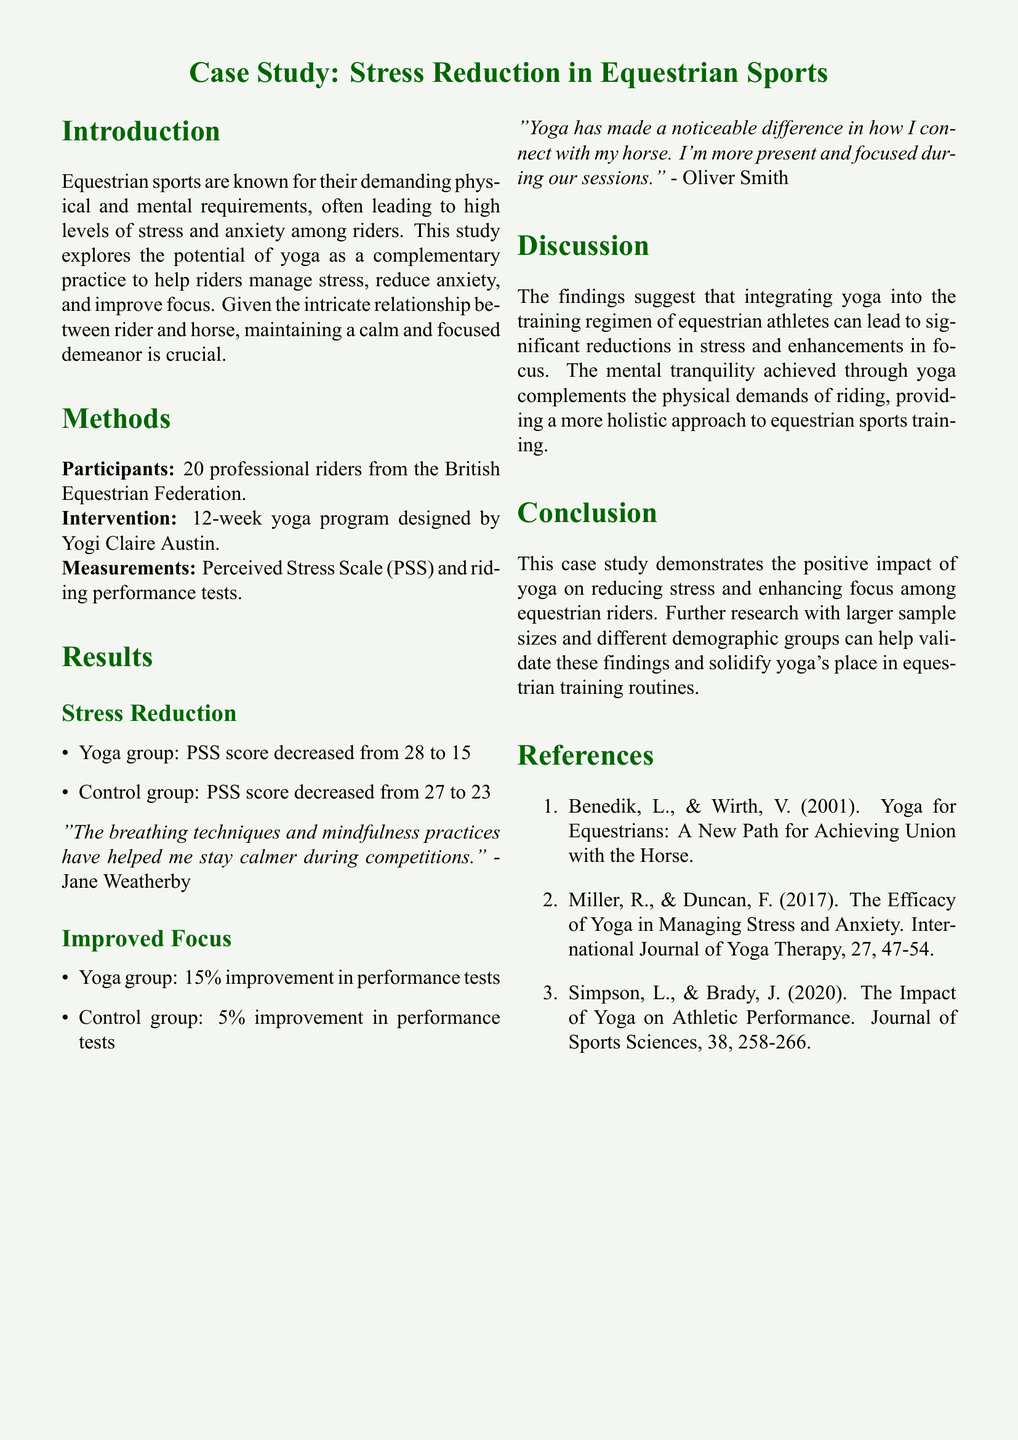What was the sample size for the study? The number of participants in the study is explicitly stated in the document, which refers to 20 professional riders.
Answer: 20 Who designed the yoga program used in the study? The document mentions that the yoga program was designed by Yogi Claire Austin.
Answer: Yogi Claire Austin What was the initial PSS score for the yoga group? The document states the yoga group's PSS score decreased from 28, providing a reference to their initial score.
Answer: 28 What percentage improvement did the yoga group achieve in performance tests? The document specifies that the yoga group had a 15% improvement in performance tests.
Answer: 15% What is one effect yoga had on the riders as described in the quotes? The quotes in the results indicate that yoga helped riders stay calmer and be more present during their sessions.
Answer: Calmer Which group had a lower decrease in PSS score? The document compares the PSS score decrease between the yoga and control groups, indicating the control group had a lower decrease.
Answer: Control group What are the names of the two references mentioned in the study? The references list provides specific names of studies, including Benedik & Wirth and Miller & Duncan.
Answer: Benedik & Wirth, Miller & Duncan What is the main conclusion drawn from the study? The document summarizes that integrating yoga can lead to stress reductions and improved focus, cementing the role of yoga in training.
Answer: Positive impact of yoga What is the duration of the yoga program implemented in the study? The document specifies that the intervention took place over a 12-week period.
Answer: 12 weeks 